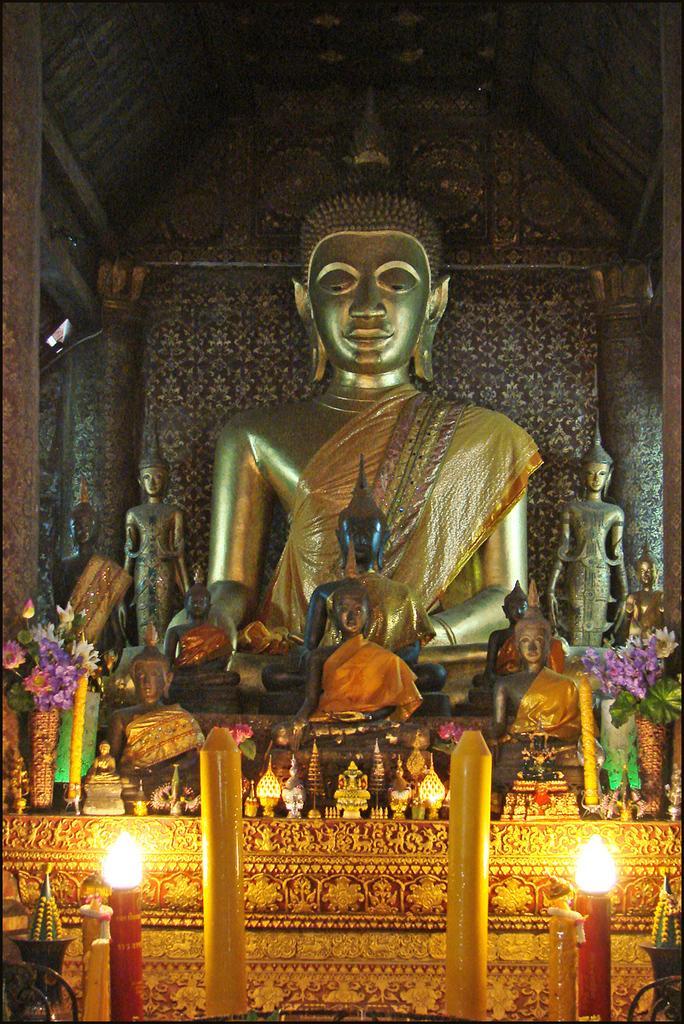Describe this image in one or two sentences. In the foreground of this picture we can see the candles and many other objects. In the center we can see the sculptures of persons. In the background there is a wall and the roof. 